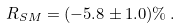<formula> <loc_0><loc_0><loc_500><loc_500>R _ { S M } = ( - 5 . 8 \pm 1 . 0 ) \% \, .</formula> 